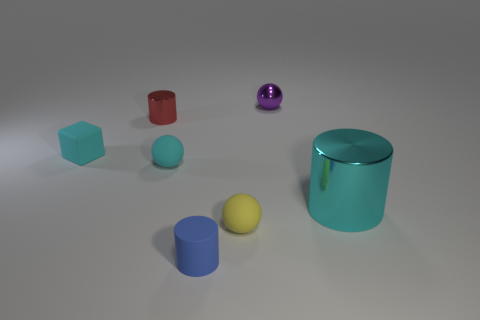Is there anything else that is the same color as the shiny ball?
Provide a succinct answer. No. Is there a cyan thing that has the same material as the purple object?
Your answer should be compact. Yes. Does the rubber ball behind the cyan cylinder have the same color as the large object?
Make the answer very short. Yes. What size is the yellow object?
Your answer should be compact. Small. Is there a large cyan metal thing in front of the tiny cylinder behind the cyan cube in front of the small red cylinder?
Keep it short and to the point. Yes. There is a big cyan metal thing; what number of shiny spheres are on the left side of it?
Give a very brief answer. 1. What number of tiny matte things are the same color as the large cylinder?
Make the answer very short. 2. How many things are tiny matte spheres that are behind the big cyan cylinder or tiny cyan matte things that are on the left side of the red cylinder?
Ensure brevity in your answer.  2. Are there more cylinders than big gray matte spheres?
Make the answer very short. Yes. What color is the metallic thing that is on the left side of the blue thing?
Provide a succinct answer. Red. 